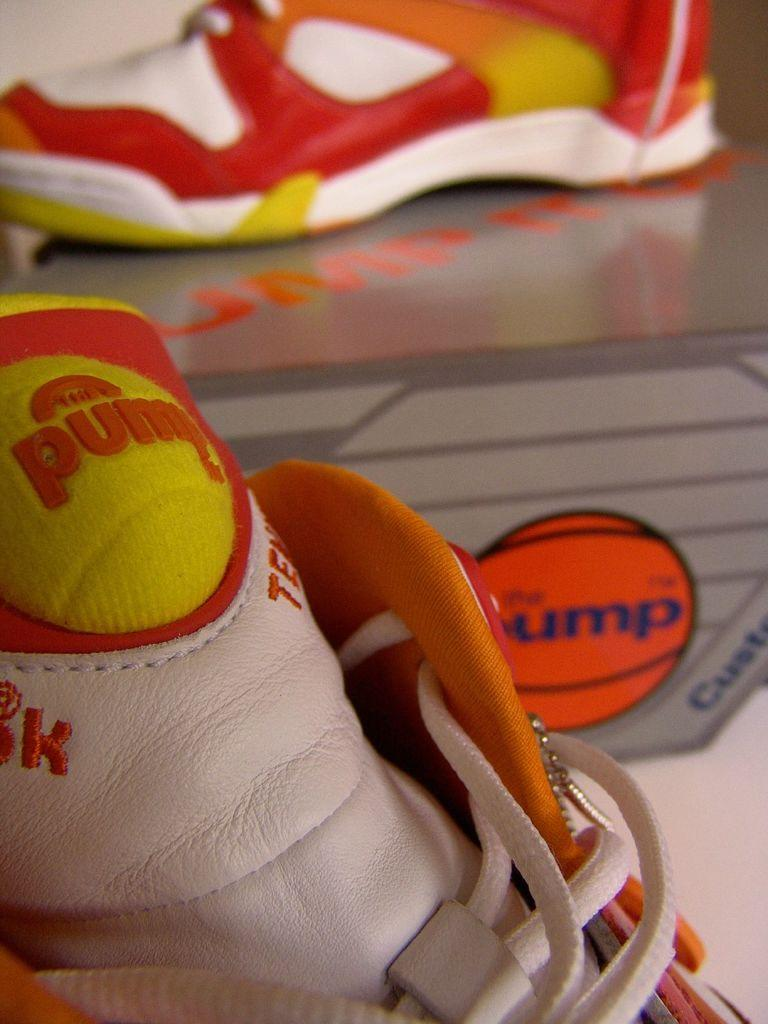What objects are placed on a surface in the image? There are shoes placed on a surface in the image. What can be seen to the right side of the image? There is a picture of a ball to the right side of the image. What type of gold is present in the image? There is no gold present in the image. What day of the week is depicted in the image? The image does not depict a specific day of the week. 